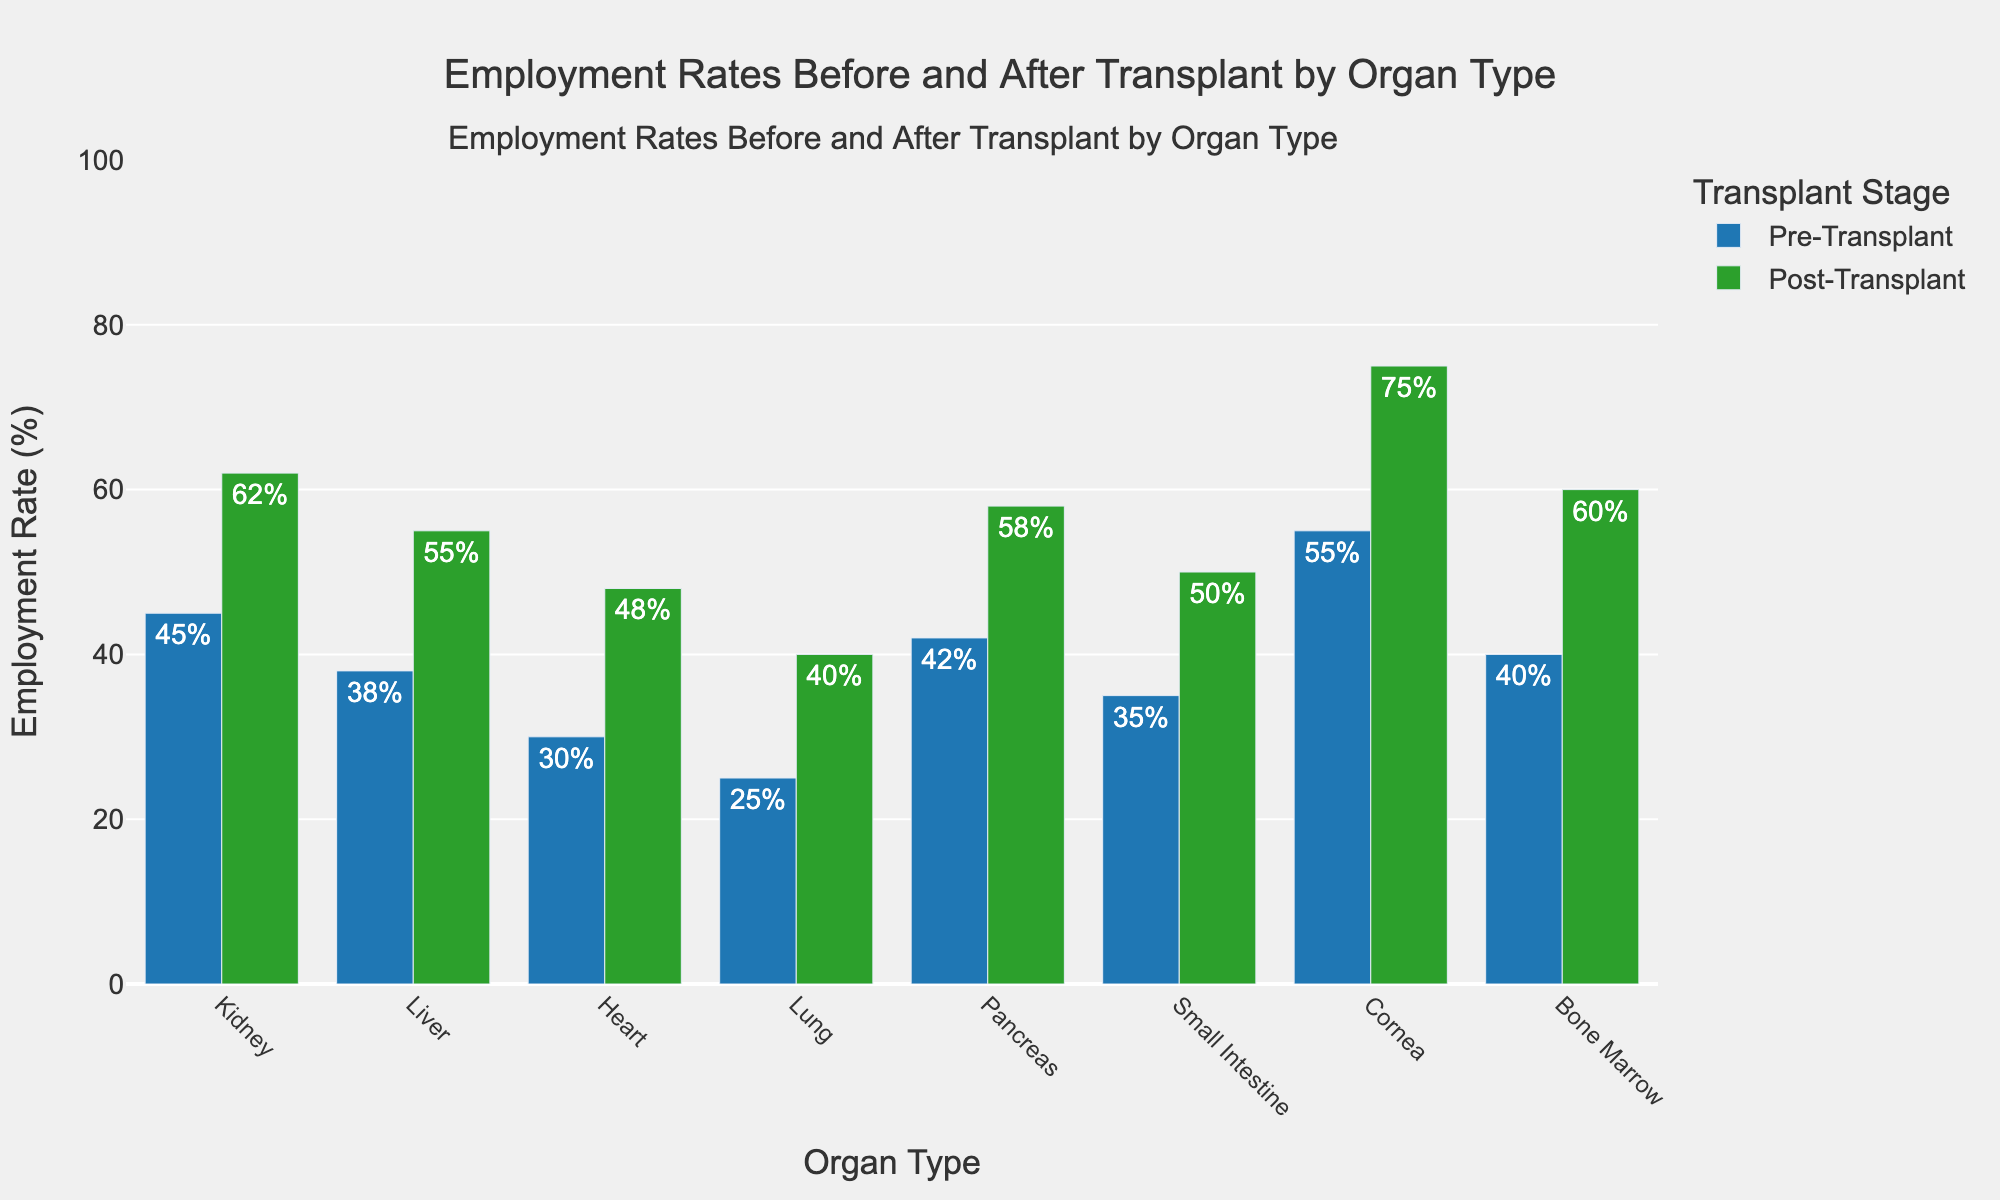What is the largest increase in employment rate from pre-transplant to post-transplant among the organ types? Identify the pre- and post-transplant employment rates for each organ. Calculate the increase for each organ by subtracting the pre-transplant rate from the post-transplant rate. The largest increase is for the cornea, from 55% to 75%, which is a 20% increase.
Answer: 20% What is the average pre-transplant employment rate among all organ types? Add up all the pre-transplant employment rates and divide by the number of organ types. The sum is 45 + 38 + 30 + 25 + 42 + 35 + 55 + 40 = 310. There are 8 organ types, so the average is 310 / 8 = 38.75%.
Answer: 38.75% Which organ type shows the highest post-transplant employment rate, and what is that rate? Compare the post-transplant employment rates for all the organ types. The cornea has the highest post-transplant employment rate at 75%.
Answer: Cornea, 75% How much higher is the post-transplant employment rate for heart transplants compared to lung transplants? Find the post-transplant employment rates for heart and lung transplants. Subtract the lung rate (40%) from the heart rate (48%). The difference is 8%.
Answer: 8% What is the combined post-transplant employment rate for kidney and pancreas transplants? Add the post-transplant employment rates for kidney (62%) and pancreas (58%). The combined rate is 62% + 58% = 120%.
Answer: 120% Which organ type experienced the smallest increase in employment rate after transplant, and what is the increase? Calculate the increase for each organ by subtracting the pre-transplant rate from the post-transplant rate. The lung has the smallest increase, from 25% to 40%, which is a 15% increase.
Answer: Lung, 15% Is the post-transplant employment rate higher or lower than the pre-transplant rate for all organ types? Compare the pre- and post-transplant rates for each organ type. The post-transplant rate is higher for all organ types in the chart.
Answer: Higher What is the difference in post-transplant employment rates between small intestine and cornea transplants? Find the post-transplant rates for small intestine (50%) and cornea (75%). Subtract the small intestine rate from the cornea rate: 75% - 50% = 25%.
Answer: 25% How much did the employment rate for bone marrow transplants increase after the transplant? Determine the pre- and post-transplant rates for bone marrow, then calculate the difference: 60% - 40% = 20%.
Answer: 20% 